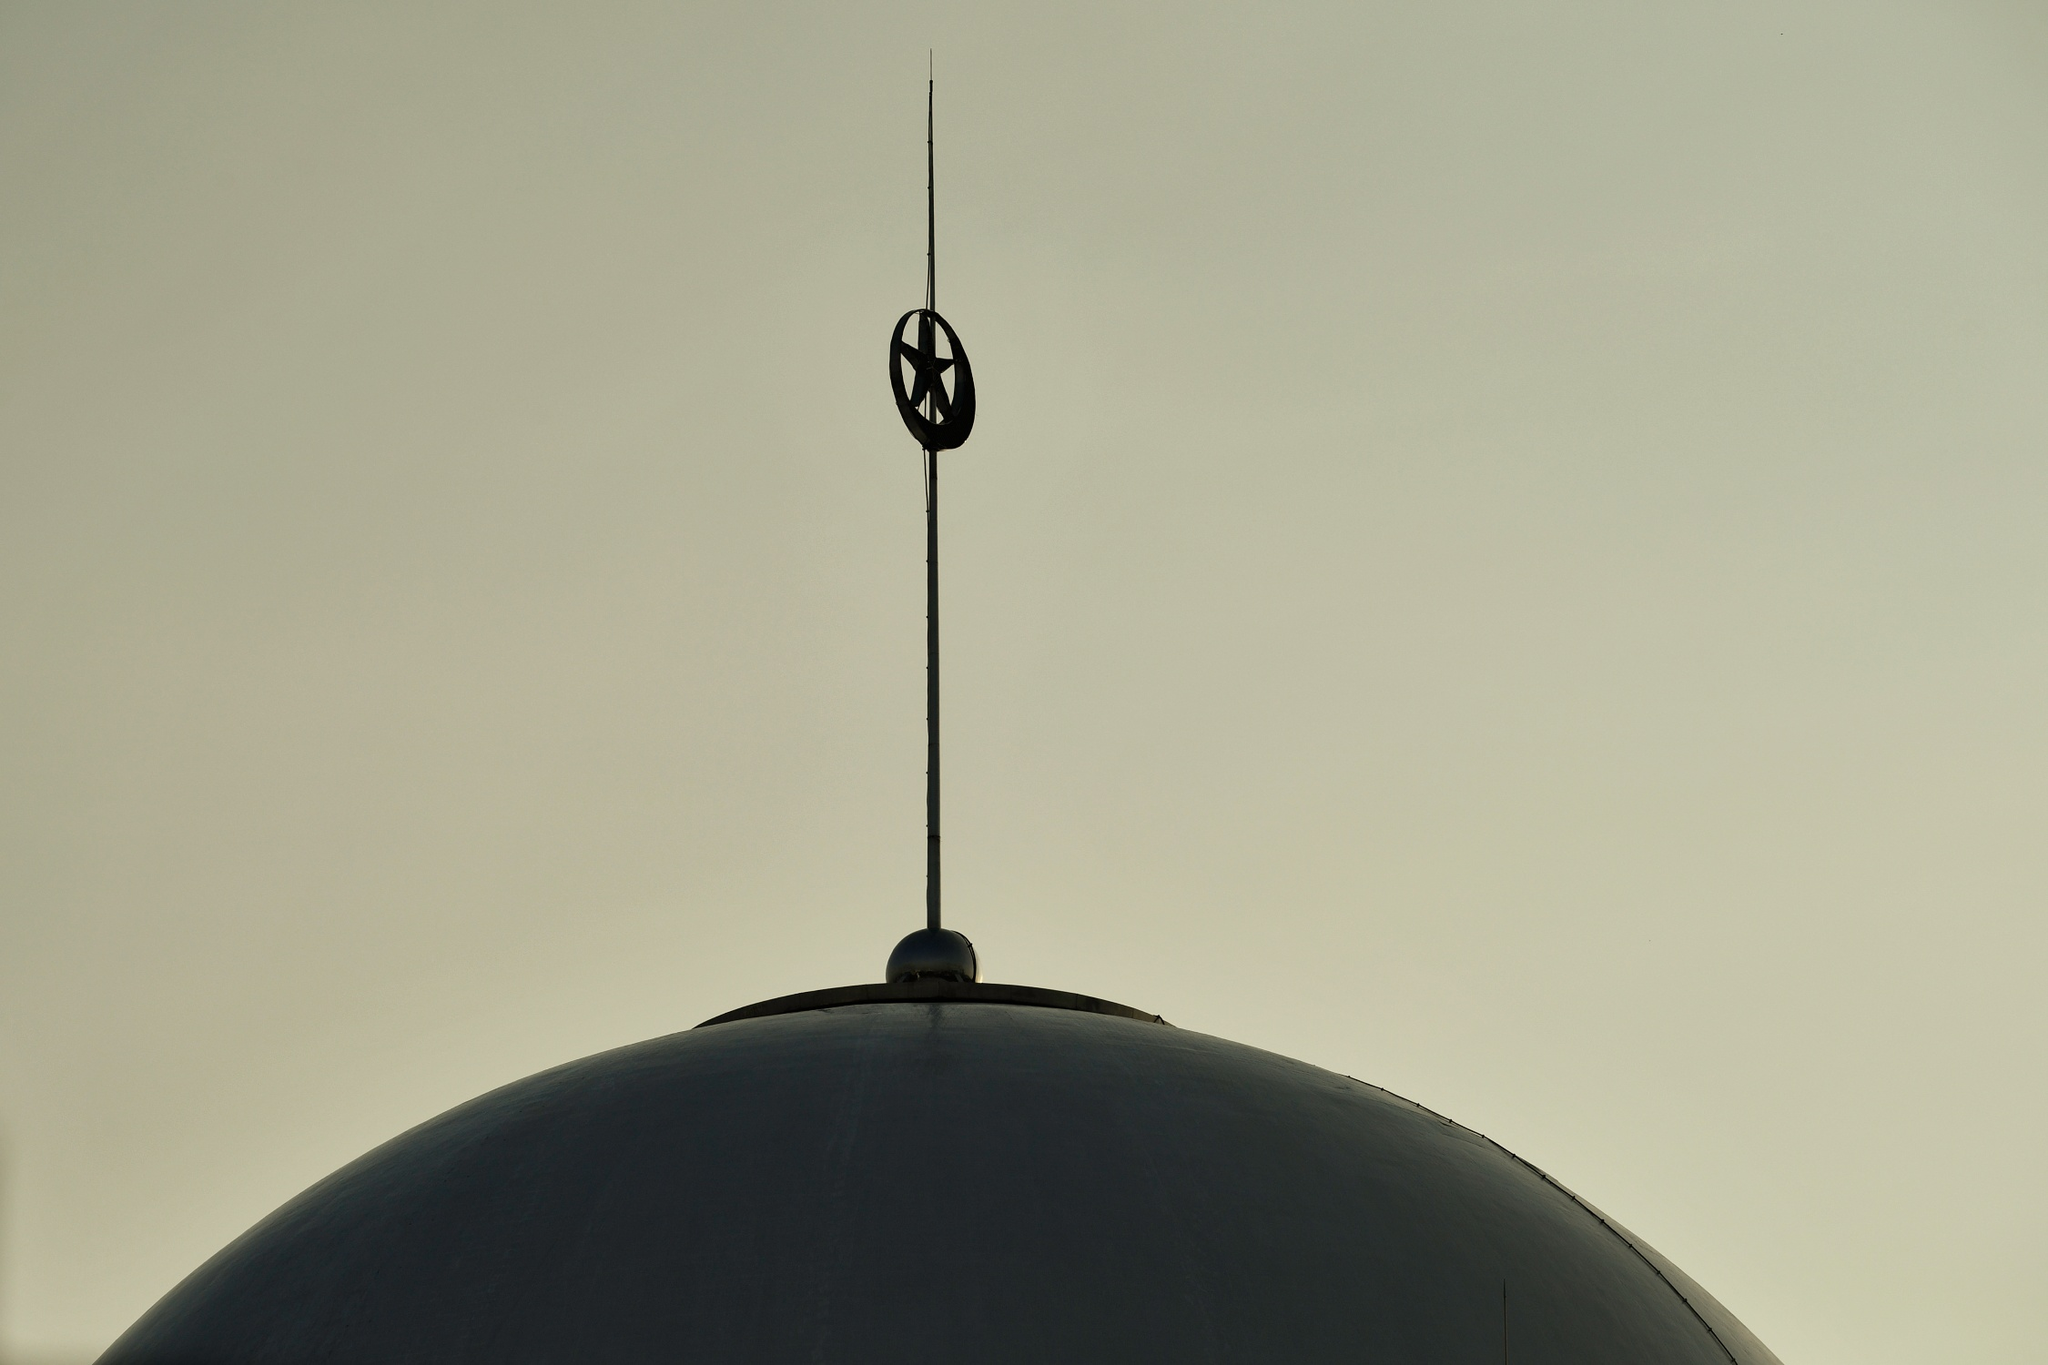What do you see happening in this image? The image provides a close-up view of a round architectural dome, possibly part of a religious or significant building, against a muted sky. The minimalistic nature of the photograph focuses on the silhouette of the dome and the slender spire, which culminates in a finial that bears a resemblance to a crescent moon, a symbol often associated with Islamic architecture. This detail could suggest the building's cultural or religious significance; however, without clearer identifying features or context, it's impossible to ascertain the exact location or purpose of the structure. 